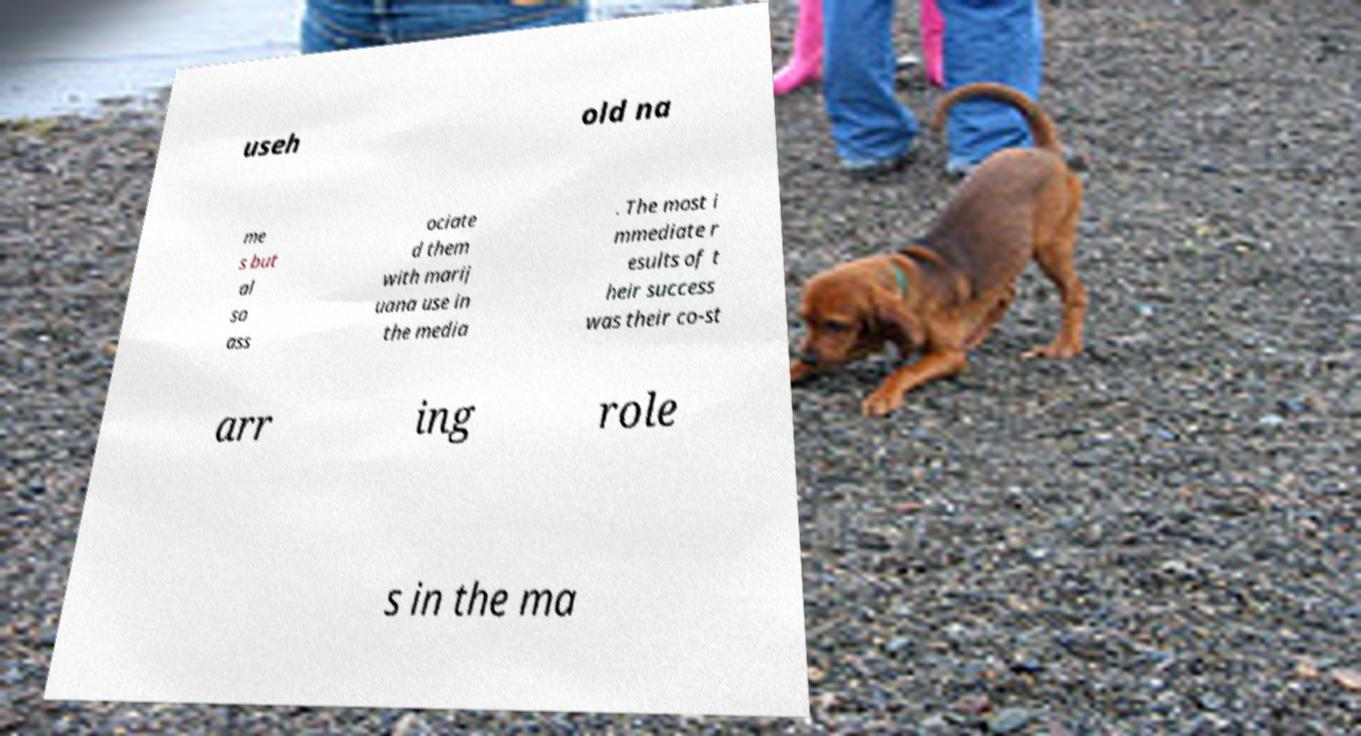Can you read and provide the text displayed in the image?This photo seems to have some interesting text. Can you extract and type it out for me? useh old na me s but al so ass ociate d them with marij uana use in the media . The most i mmediate r esults of t heir success was their co-st arr ing role s in the ma 